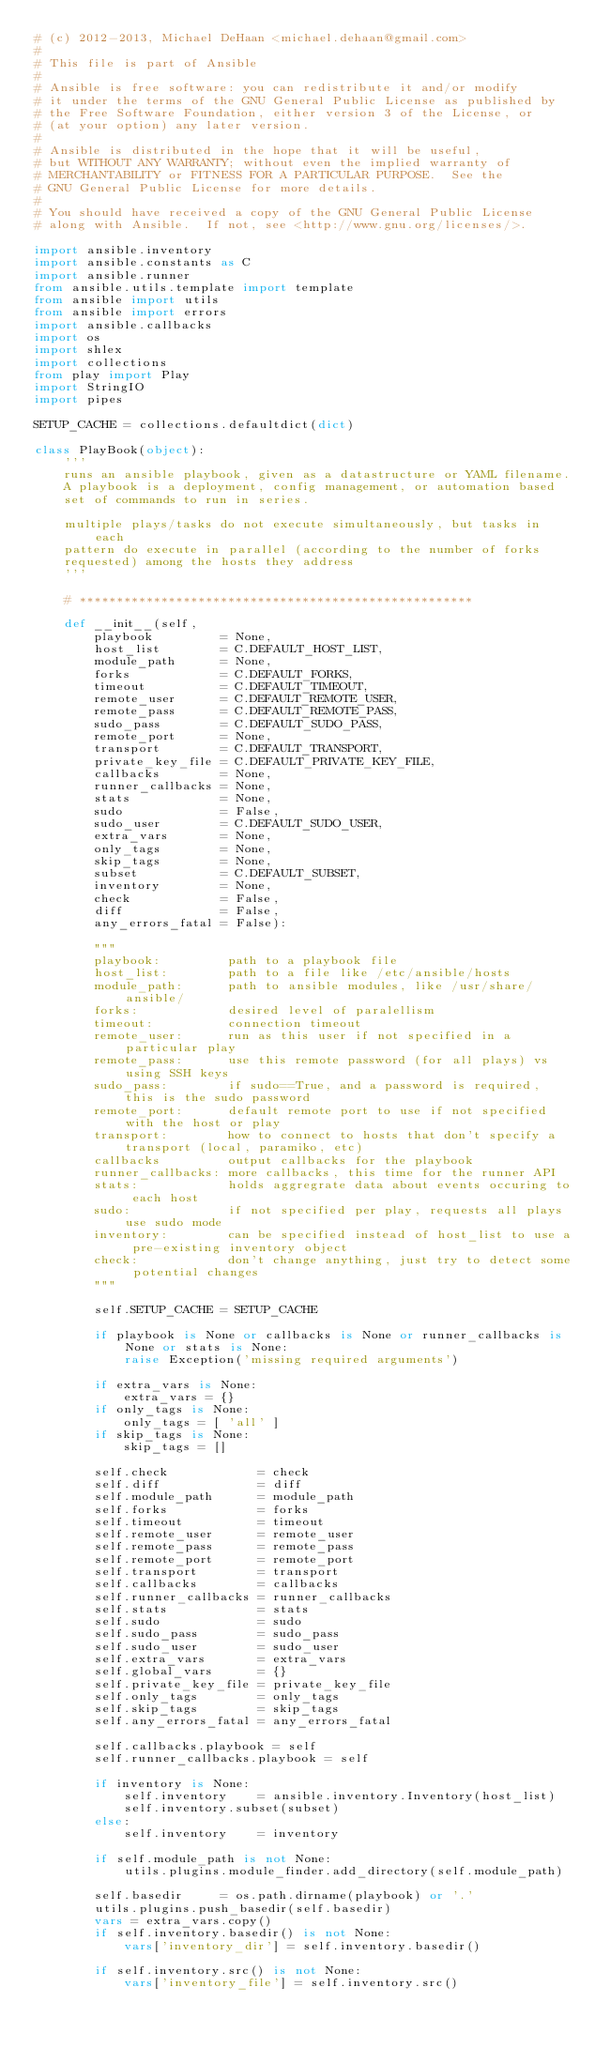Convert code to text. <code><loc_0><loc_0><loc_500><loc_500><_Python_># (c) 2012-2013, Michael DeHaan <michael.dehaan@gmail.com>
#
# This file is part of Ansible
#
# Ansible is free software: you can redistribute it and/or modify
# it under the terms of the GNU General Public License as published by
# the Free Software Foundation, either version 3 of the License, or
# (at your option) any later version.
#
# Ansible is distributed in the hope that it will be useful,
# but WITHOUT ANY WARRANTY; without even the implied warranty of
# MERCHANTABILITY or FITNESS FOR A PARTICULAR PURPOSE.  See the
# GNU General Public License for more details.
#
# You should have received a copy of the GNU General Public License
# along with Ansible.  If not, see <http://www.gnu.org/licenses/>.

import ansible.inventory
import ansible.constants as C
import ansible.runner
from ansible.utils.template import template
from ansible import utils
from ansible import errors
import ansible.callbacks
import os
import shlex
import collections
from play import Play
import StringIO
import pipes

SETUP_CACHE = collections.defaultdict(dict)

class PlayBook(object):
    '''
    runs an ansible playbook, given as a datastructure or YAML filename.
    A playbook is a deployment, config management, or automation based
    set of commands to run in series.

    multiple plays/tasks do not execute simultaneously, but tasks in each
    pattern do execute in parallel (according to the number of forks
    requested) among the hosts they address
    '''

    # *****************************************************

    def __init__(self,
        playbook         = None,
        host_list        = C.DEFAULT_HOST_LIST,
        module_path      = None,
        forks            = C.DEFAULT_FORKS,
        timeout          = C.DEFAULT_TIMEOUT,
        remote_user      = C.DEFAULT_REMOTE_USER,
        remote_pass      = C.DEFAULT_REMOTE_PASS,
        sudo_pass        = C.DEFAULT_SUDO_PASS,
        remote_port      = None,
        transport        = C.DEFAULT_TRANSPORT,
        private_key_file = C.DEFAULT_PRIVATE_KEY_FILE,
        callbacks        = None,
        runner_callbacks = None,
        stats            = None,
        sudo             = False,
        sudo_user        = C.DEFAULT_SUDO_USER,
        extra_vars       = None,
        only_tags        = None,
        skip_tags        = None,
        subset           = C.DEFAULT_SUBSET,
        inventory        = None,
        check            = False,
        diff             = False,
        any_errors_fatal = False):

        """
        playbook:         path to a playbook file
        host_list:        path to a file like /etc/ansible/hosts
        module_path:      path to ansible modules, like /usr/share/ansible/
        forks:            desired level of paralellism
        timeout:          connection timeout
        remote_user:      run as this user if not specified in a particular play
        remote_pass:      use this remote password (for all plays) vs using SSH keys
        sudo_pass:        if sudo==True, and a password is required, this is the sudo password
        remote_port:      default remote port to use if not specified with the host or play
        transport:        how to connect to hosts that don't specify a transport (local, paramiko, etc)
        callbacks         output callbacks for the playbook
        runner_callbacks: more callbacks, this time for the runner API
        stats:            holds aggregrate data about events occuring to each host
        sudo:             if not specified per play, requests all plays use sudo mode
        inventory:        can be specified instead of host_list to use a pre-existing inventory object
        check:            don't change anything, just try to detect some potential changes
        """

        self.SETUP_CACHE = SETUP_CACHE

        if playbook is None or callbacks is None or runner_callbacks is None or stats is None:
            raise Exception('missing required arguments')

        if extra_vars is None:
            extra_vars = {}
        if only_tags is None:
            only_tags = [ 'all' ]
        if skip_tags is None:
            skip_tags = []

        self.check            = check
        self.diff             = diff
        self.module_path      = module_path
        self.forks            = forks
        self.timeout          = timeout
        self.remote_user      = remote_user
        self.remote_pass      = remote_pass
        self.remote_port      = remote_port
        self.transport        = transport
        self.callbacks        = callbacks
        self.runner_callbacks = runner_callbacks
        self.stats            = stats
        self.sudo             = sudo
        self.sudo_pass        = sudo_pass
        self.sudo_user        = sudo_user
        self.extra_vars       = extra_vars
        self.global_vars      = {}
        self.private_key_file = private_key_file
        self.only_tags        = only_tags
        self.skip_tags        = skip_tags
        self.any_errors_fatal = any_errors_fatal

        self.callbacks.playbook = self
        self.runner_callbacks.playbook = self

        if inventory is None:
            self.inventory    = ansible.inventory.Inventory(host_list)
            self.inventory.subset(subset)
        else:
            self.inventory    = inventory

        if self.module_path is not None:
            utils.plugins.module_finder.add_directory(self.module_path)

        self.basedir     = os.path.dirname(playbook) or '.'
        utils.plugins.push_basedir(self.basedir)
        vars = extra_vars.copy()
        if self.inventory.basedir() is not None:
            vars['inventory_dir'] = self.inventory.basedir()

        if self.inventory.src() is not None:
            vars['inventory_file'] = self.inventory.src()
</code> 